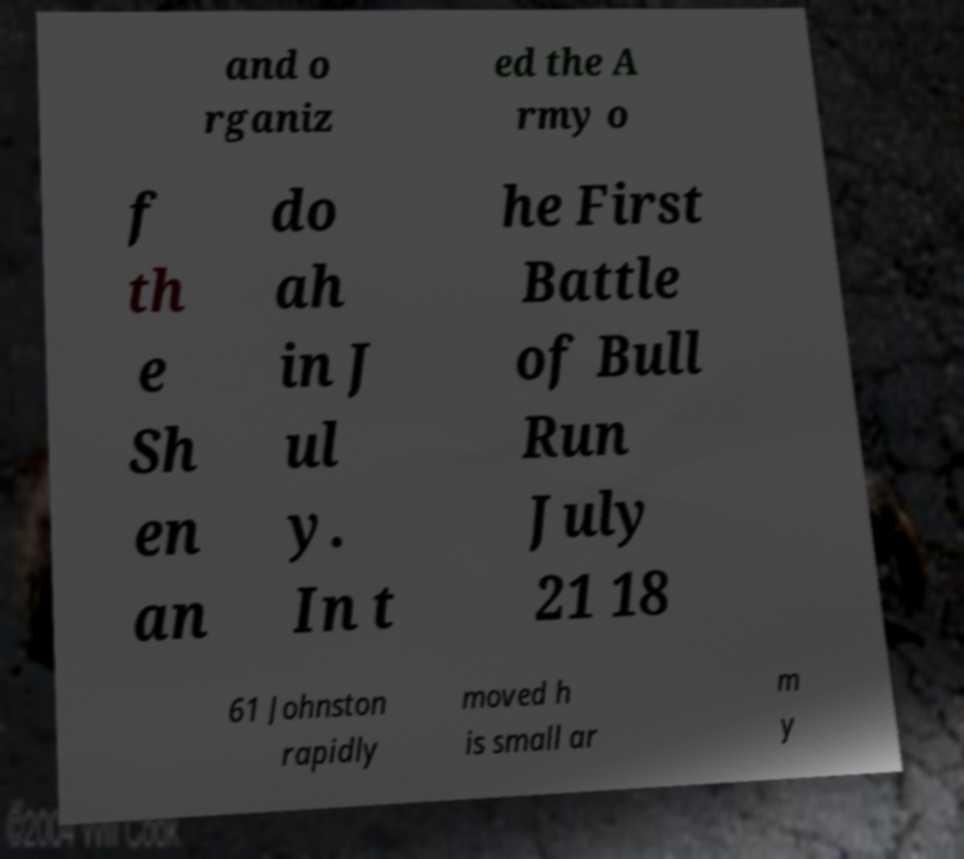Please identify and transcribe the text found in this image. and o rganiz ed the A rmy o f th e Sh en an do ah in J ul y. In t he First Battle of Bull Run July 21 18 61 Johnston rapidly moved h is small ar m y 